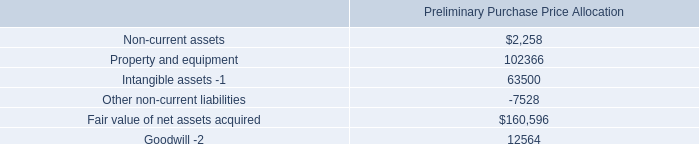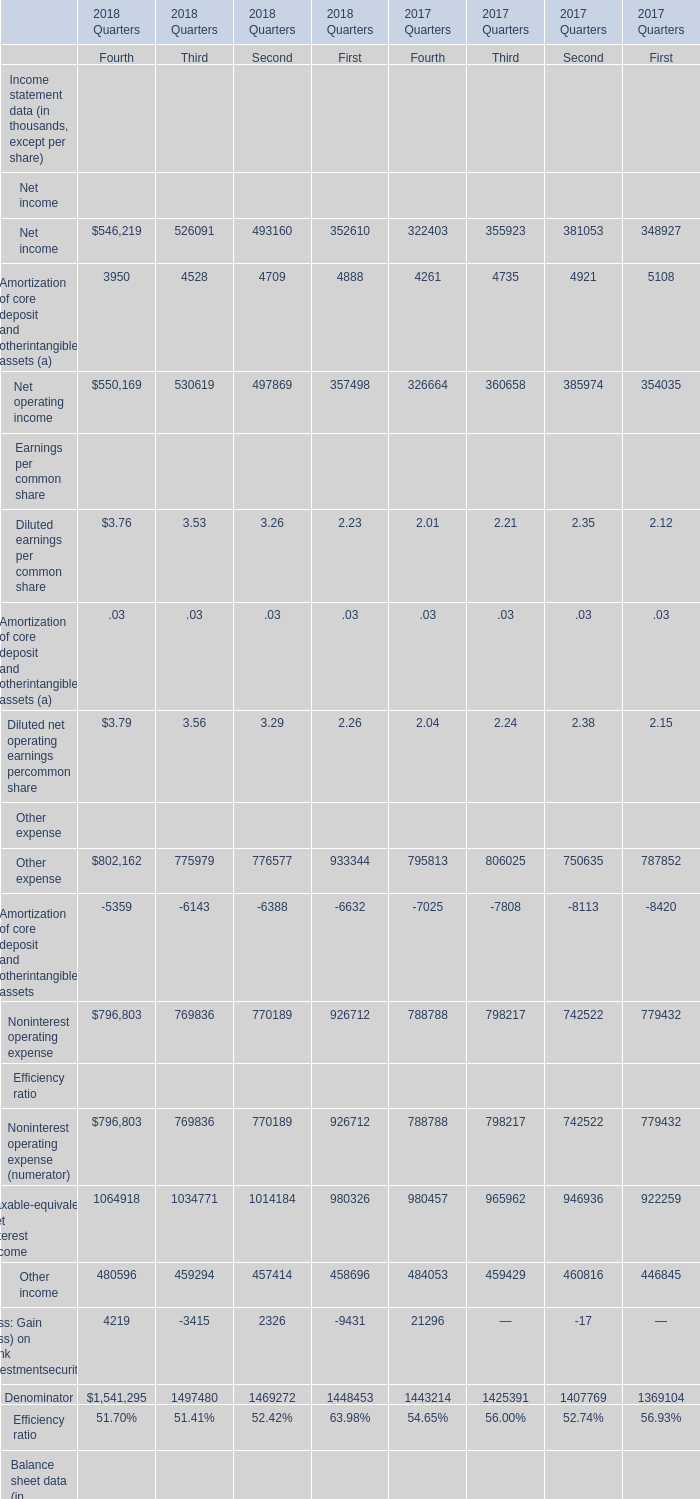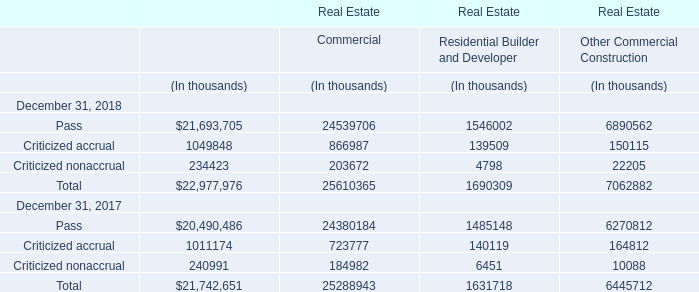What was the total amount of First in the range of 980000 and 1000000 in 2018? (in thousand) 
Computations: (1448453 + 980326)
Answer: 2428779.0. 